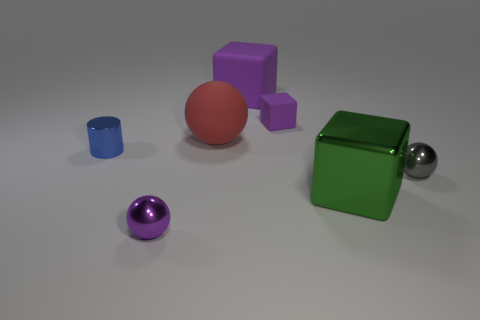Subtract all purple cubes. How many cubes are left? 1 Subtract all green cubes. How many cubes are left? 2 Add 2 big things. How many objects exist? 9 Subtract 1 spheres. How many spheres are left? 2 Subtract all blue blocks. How many gray balls are left? 1 Subtract 0 green cylinders. How many objects are left? 7 Subtract all cylinders. How many objects are left? 6 Subtract all blue spheres. Subtract all red blocks. How many spheres are left? 3 Subtract all shiny blocks. Subtract all big red matte objects. How many objects are left? 5 Add 7 small purple things. How many small purple things are left? 9 